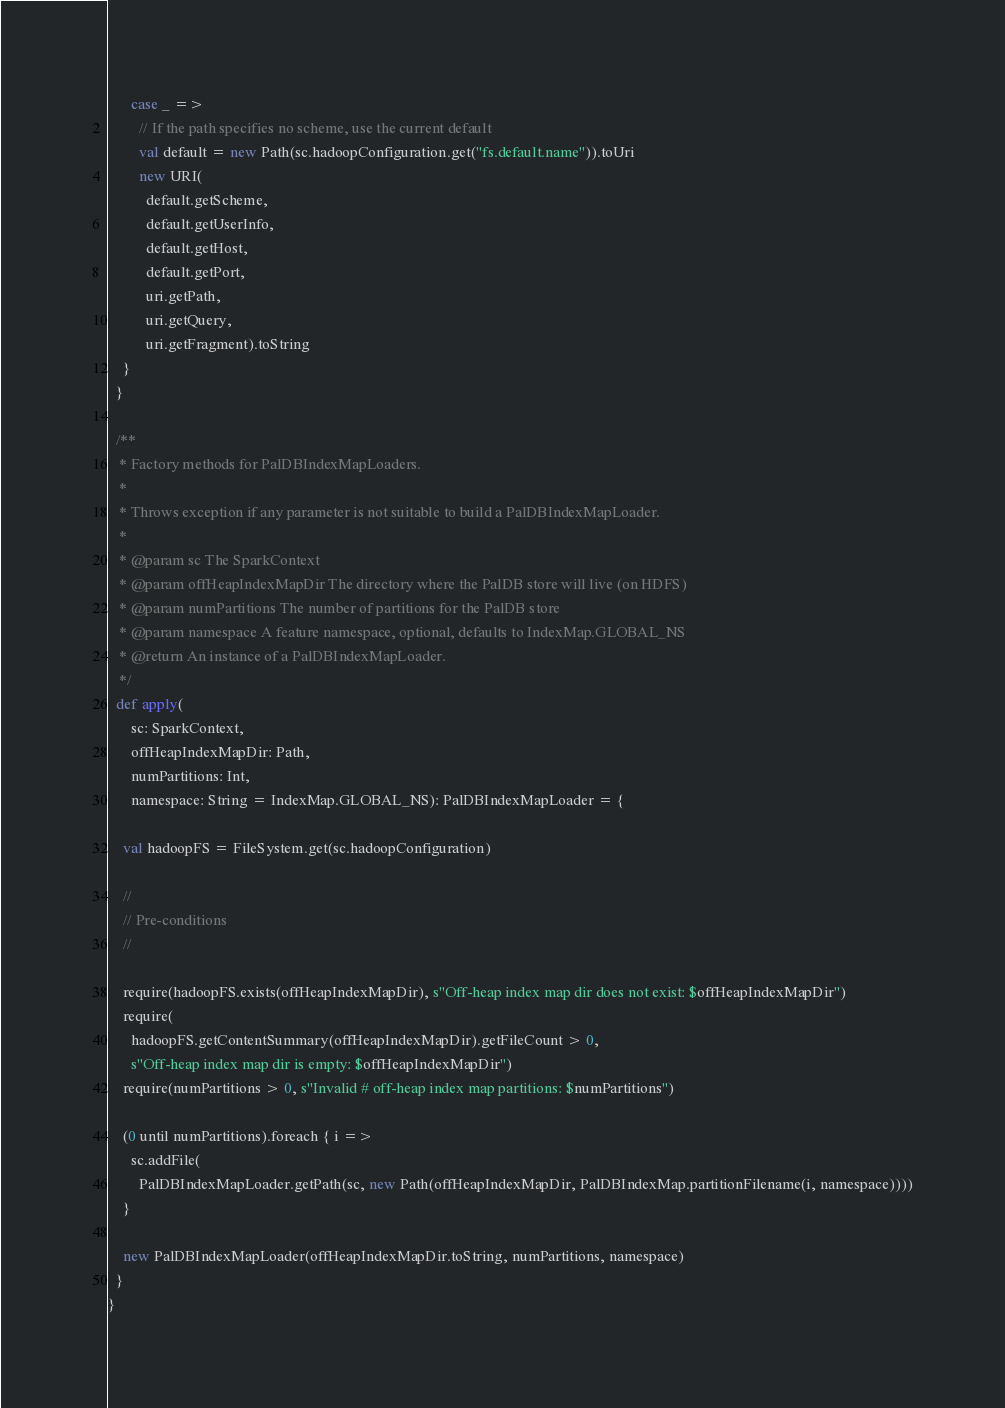<code> <loc_0><loc_0><loc_500><loc_500><_Scala_>
      case _ =>
        // If the path specifies no scheme, use the current default
        val default = new Path(sc.hadoopConfiguration.get("fs.default.name")).toUri
        new URI(
          default.getScheme,
          default.getUserInfo,
          default.getHost,
          default.getPort,
          uri.getPath,
          uri.getQuery,
          uri.getFragment).toString
    }
  }

  /**
   * Factory methods for PalDBIndexMapLoaders.
   *
   * Throws exception if any parameter is not suitable to build a PalDBIndexMapLoader.
   *
   * @param sc The SparkContext
   * @param offHeapIndexMapDir The directory where the PalDB store will live (on HDFS)
   * @param numPartitions The number of partitions for the PalDB store
   * @param namespace A feature namespace, optional, defaults to IndexMap.GLOBAL_NS
   * @return An instance of a PalDBIndexMapLoader.
   */
  def apply(
      sc: SparkContext,
      offHeapIndexMapDir: Path,
      numPartitions: Int,
      namespace: String = IndexMap.GLOBAL_NS): PalDBIndexMapLoader = {

    val hadoopFS = FileSystem.get(sc.hadoopConfiguration)

    //
    // Pre-conditions
    //

    require(hadoopFS.exists(offHeapIndexMapDir), s"Off-heap index map dir does not exist: $offHeapIndexMapDir")
    require(
      hadoopFS.getContentSummary(offHeapIndexMapDir).getFileCount > 0,
      s"Off-heap index map dir is empty: $offHeapIndexMapDir")
    require(numPartitions > 0, s"Invalid # off-heap index map partitions: $numPartitions")

    (0 until numPartitions).foreach { i =>
      sc.addFile(
        PalDBIndexMapLoader.getPath(sc, new Path(offHeapIndexMapDir, PalDBIndexMap.partitionFilename(i, namespace))))
    }

    new PalDBIndexMapLoader(offHeapIndexMapDir.toString, numPartitions, namespace)
  }
}
</code> 